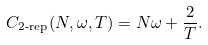<formula> <loc_0><loc_0><loc_500><loc_500>C _ { \text {2-rep} } ( N , \omega , T ) = N \omega + \frac { 2 } { T } .</formula> 